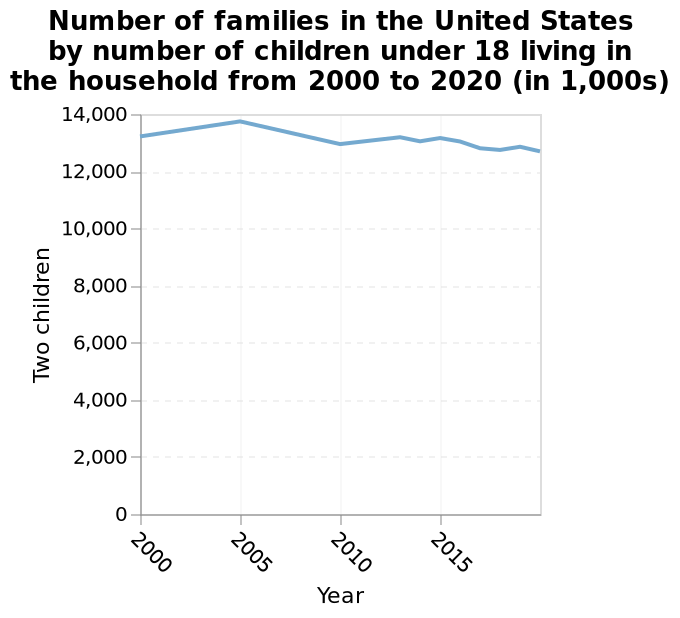<image>
please summary the statistics and relations of the chart The number of families has stayed fairly consistant. It has not gone below 12,000 nor above 14,000. What is the title of the line plot? The title of the line plot is "Number of families in the United States by number of children under 18 living in the household from 2000 to 2020 (in 1,000s)." What is the scale of the x-axis in the line chart? The scale of the x-axis is linear. 